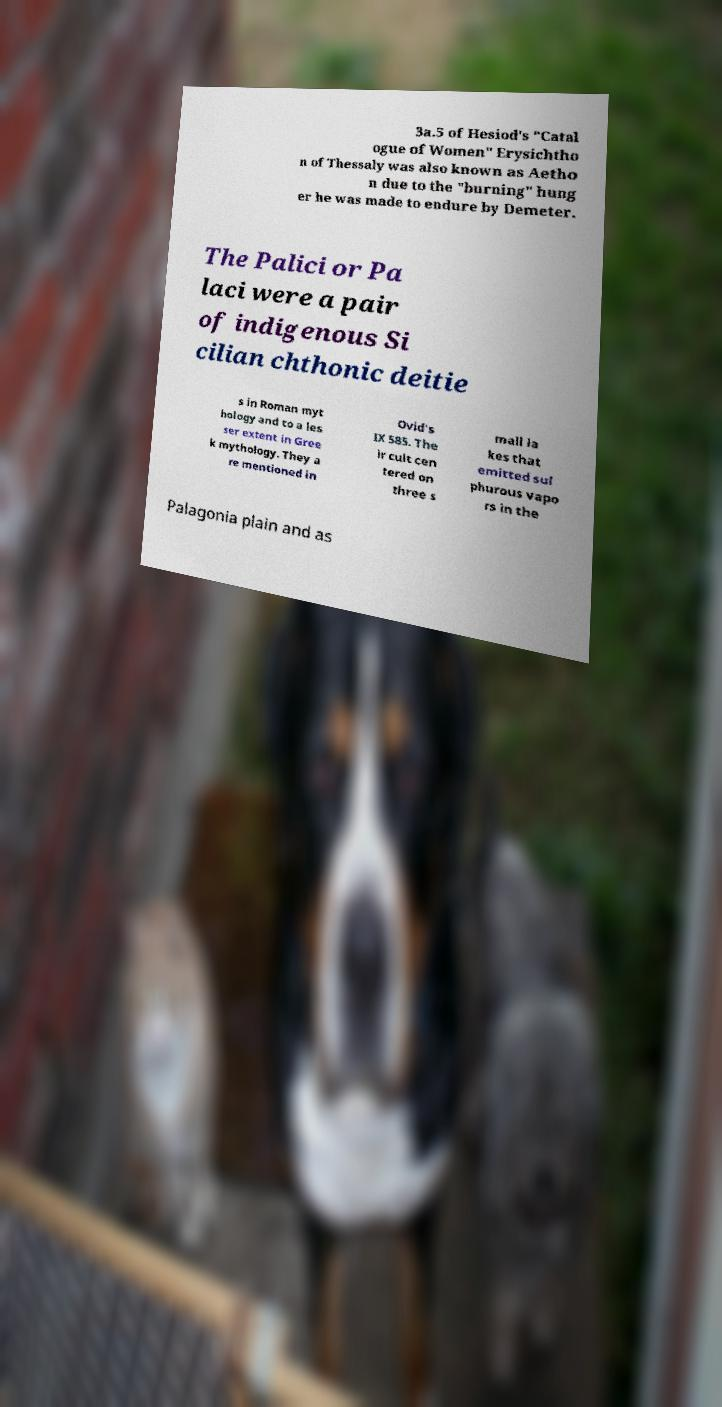For documentation purposes, I need the text within this image transcribed. Could you provide that? 3a.5 of Hesiod's "Catal ogue of Women" Erysichtho n of Thessaly was also known as Aetho n due to the "burning" hung er he was made to endure by Demeter. The Palici or Pa laci were a pair of indigenous Si cilian chthonic deitie s in Roman myt hology and to a les ser extent in Gree k mythology. They a re mentioned in Ovid's IX 585. The ir cult cen tered on three s mall la kes that emitted sul phurous vapo rs in the Palagonia plain and as 